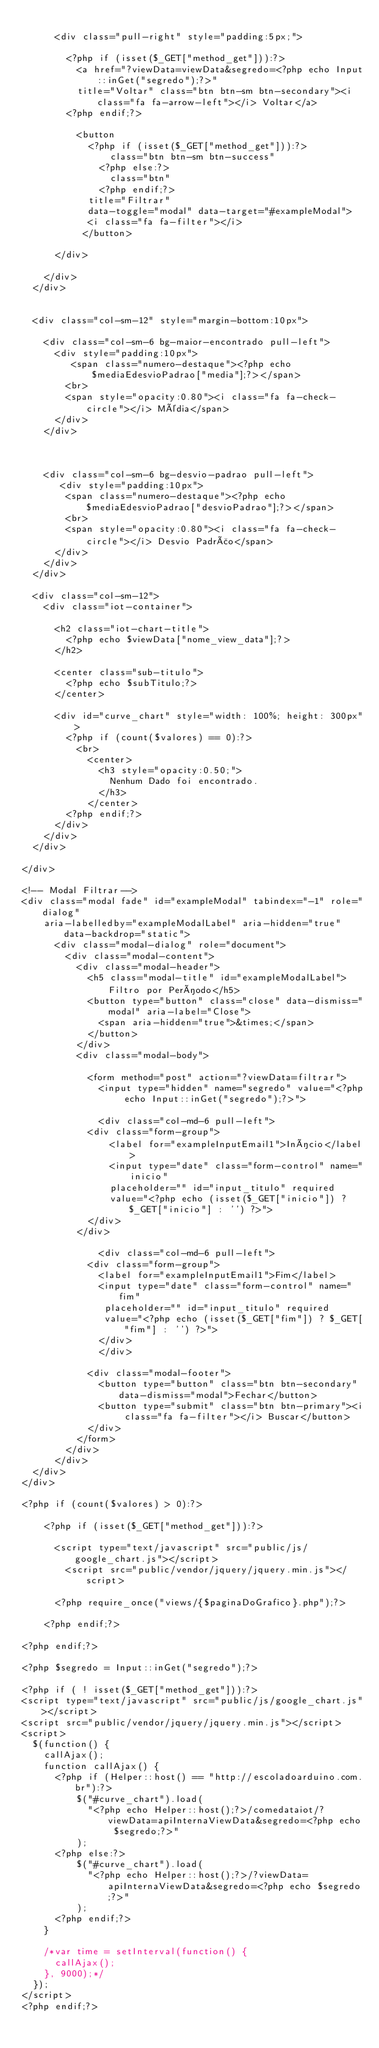<code> <loc_0><loc_0><loc_500><loc_500><_PHP_>
			<div class="pull-right" style="padding:5px;">

				<?php if (isset($_GET["method_get"])):?>
					<a href="?viewData=viewData&segredo=<?php echo Input::inGet("segredo");?>"
					title="Voltar" class="btn btn-sm btn-secondary"><i class="fa fa-arrow-left"></i> Voltar</a>
				<?php endif;?>
				
					<button 
						<?php if (isset($_GET["method_get"])):?>
						    class="btn btn-sm btn-success" 
					    <?php else:?>
					    	class="btn"
					    <?php endif;?>
						title="Filtrar"
						data-toggle="modal" data-target="#exampleModal">
						<i class="fa fa-filter"></i>
				   </button>

			</div>
			
		</div>		
	</div>


	<div class="col-sm-12" style="margin-bottom:10px">

		<div class="col-sm-6 bg-maior-encontrado pull-left">
			<div style="padding:10px">
			   <span class="numero-destaque"><?php echo $mediaEdesvioPadrao["media"];?></span>
				<br>
				<span style="opacity:0.80"><i class="fa fa-check-circle"></i> Média</span>
			</div>
		</div>
       
		

		<div class="col-sm-6 bg-desvio-padrao pull-left">
		   <div style="padding:10px">
				<span class="numero-destaque"><?php echo $mediaEdesvioPadrao["desvioPadrao"];?></span>
				<br>
				<span style="opacity:0.80"><i class="fa fa-check-circle"></i> Desvio Padrão</span>
			</div>
		</div>
	</div>

	<div class="col-sm-12">
		<div class="iot-container">

			<h2 class="iot-chart-title">
				<?php echo $viewData["nome_view_data"];?>
			</h2>

			<center class="sub-titulo">
				<?php echo $subTitulo;?>
			</center>

			<div id="curve_chart" style="width: 100%; height: 300px">
				<?php if (count($valores) == 0):?>
					<br>
				    <center>
				    	<h3 style="opacity:0.50;">
				    		Nenhum Dado foi encontrado.
				    	</h3>
				    </center>
				<?php endif;?>
			</div>
		</div>
	</div>
	
</div>

<!-- Modal Filtrar-->
<div class="modal fade" id="exampleModal" tabindex="-1" role="dialog" 
		aria-labelledby="exampleModalLabel" aria-hidden="true" data-backdrop="static">
		  <div class="modal-dialog" role="document">
		    <div class="modal-content">
		      <div class="modal-header">
		        <h5 class="modal-title" id="exampleModalLabel">Filtro por Período</h5>
		        <button type="button" class="close" data-dismiss="modal" aria-label="Close">
		          <span aria-hidden="true">&times;</span>
		        </button>
		      </div>
		      <div class="modal-body">
		        
		        <form method="post" action="?viewData=filtrar">
		        	<input type="hidden" name="segredo" value="<?php echo Input::inGet("segredo");?>">

			      	<div class="col-md-6 pull-left">
						<div class="form-group">
						    <label for="exampleInputEmail1">Início</label>
						    <input type="date" class="form-control" name="inicio" 
						    placeholder="" id="input_titulo" required
						    value="<?php echo (isset($_GET["inicio"]) ? $_GET["inicio"] : '') ?>">
						</div>
					</div>
			        
			        <div class="col-md-6 pull-left">
						<div class="form-group">
							<label for="exampleInputEmail1">Fim</label>
							<input type="date" class="form-control" name="fim" 
							 placeholder="" id="input_titulo" required
							 value="<?php echo (isset($_GET["fim"]) ? $_GET["fim"] : '') ?>">
					    </div>
			        </div>
			    
			      <div class="modal-footer">
			        <button type="button" class="btn btn-secondary" data-dismiss="modal">Fechar</button>
			        <button type="submit" class="btn btn-primary"><i class="fa fa-filter"></i> Buscar</button>
			      </div>
			    </form>
		    </div>
		  </div>
	</div>
</div>

<?php if (count($valores) > 0):?>
    
    <?php if (isset($_GET["method_get"])):?>

    	<script type="text/javascript" src="public/js/google_chart.js"></script>
        <script src="public/vendor/jquery/jquery.min.js"></script>

    	<?php require_once("views/{$paginaDoGrafico}.php");?>

    <?php endif;?>

<?php endif;?>

<?php $segredo = Input::inGet("segredo");?>

<?php if ( ! isset($_GET["method_get"])):?>
<script type="text/javascript" src="public/js/google_chart.js"></script>
<script src="public/vendor/jquery/jquery.min.js"></script>
<script>
	$(function() {
		callAjax();
		function callAjax() {
			<?php if (Helper::host() == "http://escoladoarduino.com.br"):?>
			    $("#curve_chart").load(
			    	"<?php echo Helper::host();?>/comedataiot/?viewData=apiInternaViewData&segredo=<?php echo $segredo;?>"
			    );
			<?php else:?>
			    $("#curve_chart").load(
			    	"<?php echo Helper::host();?>/?viewData=apiInternaViewData&segredo=<?php echo $segredo;?>"
			    );
			<?php endif;?>
		}

		/*var time = setInterval(function() {
			callAjax();
		}, 9000);*/
	});
</script>
<?php endif;?></code> 